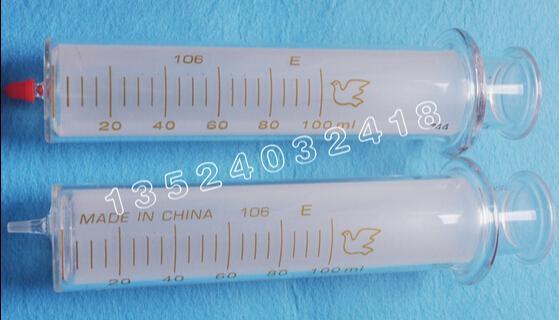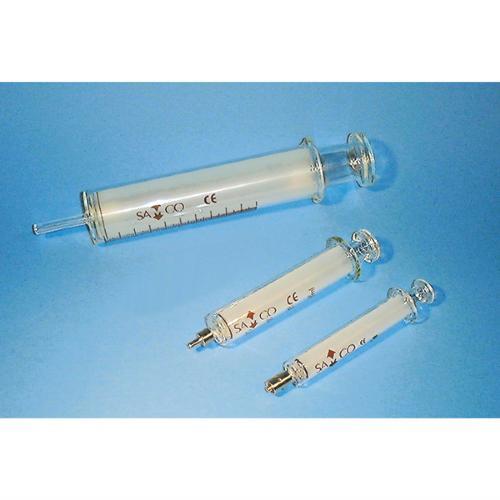The first image is the image on the left, the second image is the image on the right. Evaluate the accuracy of this statement regarding the images: "The right image contains two clear syringes.". Is it true? Answer yes or no. No. 